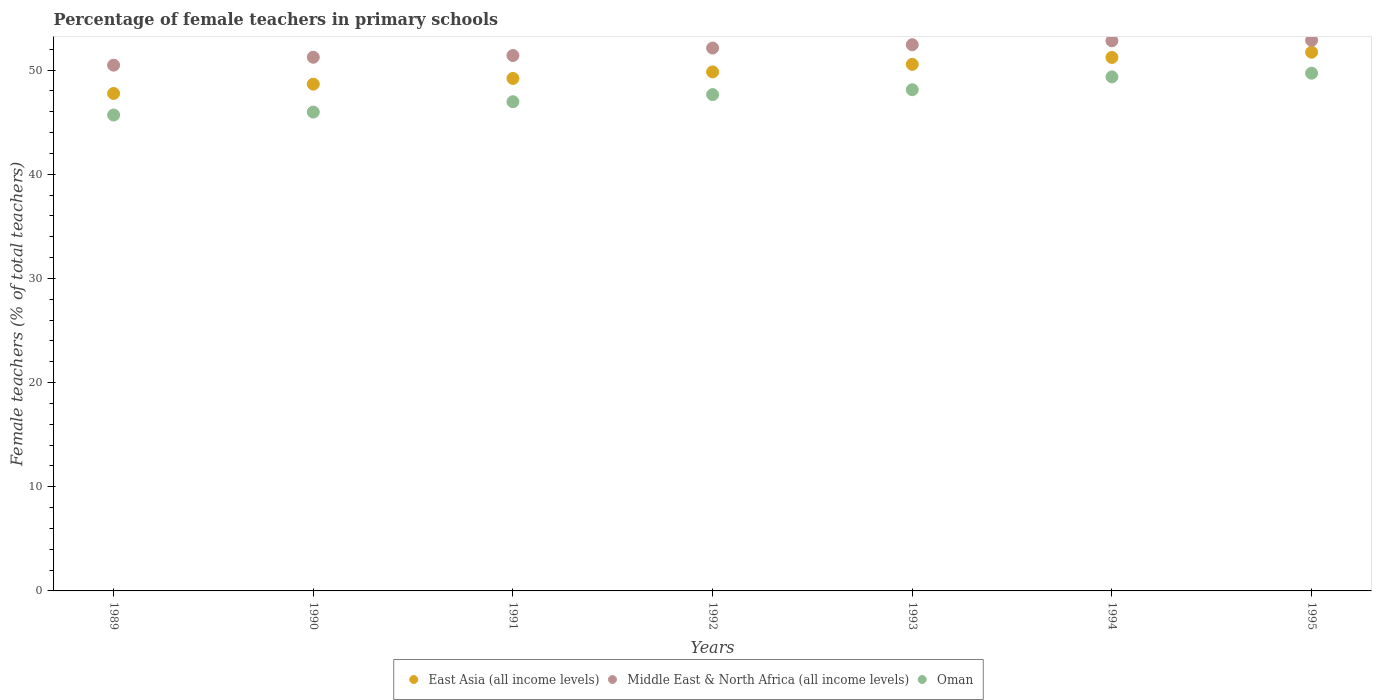Is the number of dotlines equal to the number of legend labels?
Provide a succinct answer. Yes. What is the percentage of female teachers in East Asia (all income levels) in 1993?
Keep it short and to the point. 50.56. Across all years, what is the maximum percentage of female teachers in East Asia (all income levels)?
Ensure brevity in your answer.  51.72. Across all years, what is the minimum percentage of female teachers in Middle East & North Africa (all income levels)?
Ensure brevity in your answer.  50.48. What is the total percentage of female teachers in East Asia (all income levels) in the graph?
Provide a short and direct response. 348.96. What is the difference between the percentage of female teachers in Oman in 1993 and that in 1994?
Your answer should be very brief. -1.23. What is the difference between the percentage of female teachers in Middle East & North Africa (all income levels) in 1989 and the percentage of female teachers in East Asia (all income levels) in 1995?
Ensure brevity in your answer.  -1.24. What is the average percentage of female teachers in East Asia (all income levels) per year?
Make the answer very short. 49.85. In the year 1989, what is the difference between the percentage of female teachers in Oman and percentage of female teachers in Middle East & North Africa (all income levels)?
Provide a succinct answer. -4.79. In how many years, is the percentage of female teachers in Oman greater than 10 %?
Ensure brevity in your answer.  7. What is the ratio of the percentage of female teachers in East Asia (all income levels) in 1990 to that in 1991?
Your response must be concise. 0.99. Is the difference between the percentage of female teachers in Oman in 1989 and 1992 greater than the difference between the percentage of female teachers in Middle East & North Africa (all income levels) in 1989 and 1992?
Your answer should be very brief. No. What is the difference between the highest and the second highest percentage of female teachers in Middle East & North Africa (all income levels)?
Your answer should be very brief. 0.05. What is the difference between the highest and the lowest percentage of female teachers in Oman?
Offer a very short reply. 4.02. In how many years, is the percentage of female teachers in Oman greater than the average percentage of female teachers in Oman taken over all years?
Your answer should be very brief. 4. Is the sum of the percentage of female teachers in Oman in 1991 and 1995 greater than the maximum percentage of female teachers in East Asia (all income levels) across all years?
Offer a terse response. Yes. Does the percentage of female teachers in Oman monotonically increase over the years?
Make the answer very short. Yes. Is the percentage of female teachers in East Asia (all income levels) strictly less than the percentage of female teachers in Middle East & North Africa (all income levels) over the years?
Your answer should be compact. Yes. How many dotlines are there?
Your answer should be compact. 3. How many years are there in the graph?
Your answer should be compact. 7. What is the difference between two consecutive major ticks on the Y-axis?
Keep it short and to the point. 10. Does the graph contain any zero values?
Offer a very short reply. No. What is the title of the graph?
Your answer should be very brief. Percentage of female teachers in primary schools. What is the label or title of the X-axis?
Your response must be concise. Years. What is the label or title of the Y-axis?
Your response must be concise. Female teachers (% of total teachers). What is the Female teachers (% of total teachers) in East Asia (all income levels) in 1989?
Offer a terse response. 47.76. What is the Female teachers (% of total teachers) of Middle East & North Africa (all income levels) in 1989?
Give a very brief answer. 50.48. What is the Female teachers (% of total teachers) of Oman in 1989?
Provide a succinct answer. 45.69. What is the Female teachers (% of total teachers) of East Asia (all income levels) in 1990?
Your answer should be compact. 48.66. What is the Female teachers (% of total teachers) in Middle East & North Africa (all income levels) in 1990?
Offer a terse response. 51.24. What is the Female teachers (% of total teachers) in Oman in 1990?
Your answer should be very brief. 45.98. What is the Female teachers (% of total teachers) in East Asia (all income levels) in 1991?
Make the answer very short. 49.21. What is the Female teachers (% of total teachers) of Middle East & North Africa (all income levels) in 1991?
Keep it short and to the point. 51.41. What is the Female teachers (% of total teachers) in Oman in 1991?
Give a very brief answer. 46.97. What is the Female teachers (% of total teachers) in East Asia (all income levels) in 1992?
Provide a succinct answer. 49.83. What is the Female teachers (% of total teachers) of Middle East & North Africa (all income levels) in 1992?
Provide a short and direct response. 52.12. What is the Female teachers (% of total teachers) in Oman in 1992?
Offer a very short reply. 47.65. What is the Female teachers (% of total teachers) of East Asia (all income levels) in 1993?
Keep it short and to the point. 50.56. What is the Female teachers (% of total teachers) in Middle East & North Africa (all income levels) in 1993?
Give a very brief answer. 52.44. What is the Female teachers (% of total teachers) of Oman in 1993?
Keep it short and to the point. 48.12. What is the Female teachers (% of total teachers) in East Asia (all income levels) in 1994?
Keep it short and to the point. 51.22. What is the Female teachers (% of total teachers) in Middle East & North Africa (all income levels) in 1994?
Offer a very short reply. 52.82. What is the Female teachers (% of total teachers) of Oman in 1994?
Ensure brevity in your answer.  49.35. What is the Female teachers (% of total teachers) in East Asia (all income levels) in 1995?
Give a very brief answer. 51.72. What is the Female teachers (% of total teachers) of Middle East & North Africa (all income levels) in 1995?
Offer a very short reply. 52.87. What is the Female teachers (% of total teachers) of Oman in 1995?
Your response must be concise. 49.71. Across all years, what is the maximum Female teachers (% of total teachers) of East Asia (all income levels)?
Your answer should be very brief. 51.72. Across all years, what is the maximum Female teachers (% of total teachers) of Middle East & North Africa (all income levels)?
Ensure brevity in your answer.  52.87. Across all years, what is the maximum Female teachers (% of total teachers) in Oman?
Your response must be concise. 49.71. Across all years, what is the minimum Female teachers (% of total teachers) of East Asia (all income levels)?
Keep it short and to the point. 47.76. Across all years, what is the minimum Female teachers (% of total teachers) in Middle East & North Africa (all income levels)?
Offer a very short reply. 50.48. Across all years, what is the minimum Female teachers (% of total teachers) in Oman?
Your answer should be compact. 45.69. What is the total Female teachers (% of total teachers) in East Asia (all income levels) in the graph?
Ensure brevity in your answer.  348.96. What is the total Female teachers (% of total teachers) of Middle East & North Africa (all income levels) in the graph?
Your answer should be compact. 363.38. What is the total Female teachers (% of total teachers) in Oman in the graph?
Your response must be concise. 333.47. What is the difference between the Female teachers (% of total teachers) of East Asia (all income levels) in 1989 and that in 1990?
Your response must be concise. -0.9. What is the difference between the Female teachers (% of total teachers) in Middle East & North Africa (all income levels) in 1989 and that in 1990?
Your response must be concise. -0.76. What is the difference between the Female teachers (% of total teachers) in Oman in 1989 and that in 1990?
Give a very brief answer. -0.29. What is the difference between the Female teachers (% of total teachers) of East Asia (all income levels) in 1989 and that in 1991?
Your response must be concise. -1.44. What is the difference between the Female teachers (% of total teachers) in Middle East & North Africa (all income levels) in 1989 and that in 1991?
Your answer should be compact. -0.92. What is the difference between the Female teachers (% of total teachers) in Oman in 1989 and that in 1991?
Give a very brief answer. -1.28. What is the difference between the Female teachers (% of total teachers) in East Asia (all income levels) in 1989 and that in 1992?
Your answer should be very brief. -2.07. What is the difference between the Female teachers (% of total teachers) in Middle East & North Africa (all income levels) in 1989 and that in 1992?
Provide a short and direct response. -1.64. What is the difference between the Female teachers (% of total teachers) in Oman in 1989 and that in 1992?
Give a very brief answer. -1.96. What is the difference between the Female teachers (% of total teachers) of East Asia (all income levels) in 1989 and that in 1993?
Offer a terse response. -2.8. What is the difference between the Female teachers (% of total teachers) of Middle East & North Africa (all income levels) in 1989 and that in 1993?
Give a very brief answer. -1.96. What is the difference between the Female teachers (% of total teachers) in Oman in 1989 and that in 1993?
Offer a terse response. -2.43. What is the difference between the Female teachers (% of total teachers) in East Asia (all income levels) in 1989 and that in 1994?
Your response must be concise. -3.46. What is the difference between the Female teachers (% of total teachers) of Middle East & North Africa (all income levels) in 1989 and that in 1994?
Keep it short and to the point. -2.34. What is the difference between the Female teachers (% of total teachers) in Oman in 1989 and that in 1994?
Keep it short and to the point. -3.66. What is the difference between the Female teachers (% of total teachers) of East Asia (all income levels) in 1989 and that in 1995?
Offer a very short reply. -3.96. What is the difference between the Female teachers (% of total teachers) in Middle East & North Africa (all income levels) in 1989 and that in 1995?
Offer a terse response. -2.39. What is the difference between the Female teachers (% of total teachers) of Oman in 1989 and that in 1995?
Offer a terse response. -4.02. What is the difference between the Female teachers (% of total teachers) of East Asia (all income levels) in 1990 and that in 1991?
Your answer should be very brief. -0.55. What is the difference between the Female teachers (% of total teachers) in Middle East & North Africa (all income levels) in 1990 and that in 1991?
Make the answer very short. -0.16. What is the difference between the Female teachers (% of total teachers) of Oman in 1990 and that in 1991?
Offer a very short reply. -0.99. What is the difference between the Female teachers (% of total teachers) in East Asia (all income levels) in 1990 and that in 1992?
Ensure brevity in your answer.  -1.17. What is the difference between the Female teachers (% of total teachers) in Middle East & North Africa (all income levels) in 1990 and that in 1992?
Your response must be concise. -0.88. What is the difference between the Female teachers (% of total teachers) in Oman in 1990 and that in 1992?
Give a very brief answer. -1.68. What is the difference between the Female teachers (% of total teachers) in East Asia (all income levels) in 1990 and that in 1993?
Provide a short and direct response. -1.9. What is the difference between the Female teachers (% of total teachers) of Middle East & North Africa (all income levels) in 1990 and that in 1993?
Your answer should be compact. -1.2. What is the difference between the Female teachers (% of total teachers) of Oman in 1990 and that in 1993?
Provide a short and direct response. -2.15. What is the difference between the Female teachers (% of total teachers) in East Asia (all income levels) in 1990 and that in 1994?
Your answer should be very brief. -2.56. What is the difference between the Female teachers (% of total teachers) in Middle East & North Africa (all income levels) in 1990 and that in 1994?
Keep it short and to the point. -1.58. What is the difference between the Female teachers (% of total teachers) in Oman in 1990 and that in 1994?
Make the answer very short. -3.38. What is the difference between the Female teachers (% of total teachers) in East Asia (all income levels) in 1990 and that in 1995?
Make the answer very short. -3.07. What is the difference between the Female teachers (% of total teachers) in Middle East & North Africa (all income levels) in 1990 and that in 1995?
Offer a very short reply. -1.63. What is the difference between the Female teachers (% of total teachers) of Oman in 1990 and that in 1995?
Make the answer very short. -3.73. What is the difference between the Female teachers (% of total teachers) of East Asia (all income levels) in 1991 and that in 1992?
Make the answer very short. -0.63. What is the difference between the Female teachers (% of total teachers) of Middle East & North Africa (all income levels) in 1991 and that in 1992?
Ensure brevity in your answer.  -0.72. What is the difference between the Female teachers (% of total teachers) of Oman in 1991 and that in 1992?
Your response must be concise. -0.68. What is the difference between the Female teachers (% of total teachers) in East Asia (all income levels) in 1991 and that in 1993?
Give a very brief answer. -1.35. What is the difference between the Female teachers (% of total teachers) of Middle East & North Africa (all income levels) in 1991 and that in 1993?
Offer a terse response. -1.04. What is the difference between the Female teachers (% of total teachers) of Oman in 1991 and that in 1993?
Offer a very short reply. -1.15. What is the difference between the Female teachers (% of total teachers) in East Asia (all income levels) in 1991 and that in 1994?
Your answer should be compact. -2.02. What is the difference between the Female teachers (% of total teachers) in Middle East & North Africa (all income levels) in 1991 and that in 1994?
Your answer should be compact. -1.41. What is the difference between the Female teachers (% of total teachers) in Oman in 1991 and that in 1994?
Provide a short and direct response. -2.39. What is the difference between the Female teachers (% of total teachers) of East Asia (all income levels) in 1991 and that in 1995?
Give a very brief answer. -2.52. What is the difference between the Female teachers (% of total teachers) of Middle East & North Africa (all income levels) in 1991 and that in 1995?
Offer a terse response. -1.46. What is the difference between the Female teachers (% of total teachers) in Oman in 1991 and that in 1995?
Offer a terse response. -2.74. What is the difference between the Female teachers (% of total teachers) in East Asia (all income levels) in 1992 and that in 1993?
Keep it short and to the point. -0.73. What is the difference between the Female teachers (% of total teachers) of Middle East & North Africa (all income levels) in 1992 and that in 1993?
Make the answer very short. -0.32. What is the difference between the Female teachers (% of total teachers) of Oman in 1992 and that in 1993?
Offer a very short reply. -0.47. What is the difference between the Female teachers (% of total teachers) in East Asia (all income levels) in 1992 and that in 1994?
Your answer should be compact. -1.39. What is the difference between the Female teachers (% of total teachers) in Middle East & North Africa (all income levels) in 1992 and that in 1994?
Provide a short and direct response. -0.69. What is the difference between the Female teachers (% of total teachers) in Oman in 1992 and that in 1994?
Provide a succinct answer. -1.7. What is the difference between the Female teachers (% of total teachers) of East Asia (all income levels) in 1992 and that in 1995?
Offer a terse response. -1.89. What is the difference between the Female teachers (% of total teachers) of Middle East & North Africa (all income levels) in 1992 and that in 1995?
Ensure brevity in your answer.  -0.74. What is the difference between the Female teachers (% of total teachers) in Oman in 1992 and that in 1995?
Keep it short and to the point. -2.05. What is the difference between the Female teachers (% of total teachers) in East Asia (all income levels) in 1993 and that in 1994?
Keep it short and to the point. -0.66. What is the difference between the Female teachers (% of total teachers) in Middle East & North Africa (all income levels) in 1993 and that in 1994?
Ensure brevity in your answer.  -0.37. What is the difference between the Female teachers (% of total teachers) in Oman in 1993 and that in 1994?
Make the answer very short. -1.23. What is the difference between the Female teachers (% of total teachers) of East Asia (all income levels) in 1993 and that in 1995?
Your answer should be compact. -1.16. What is the difference between the Female teachers (% of total teachers) in Middle East & North Africa (all income levels) in 1993 and that in 1995?
Make the answer very short. -0.42. What is the difference between the Female teachers (% of total teachers) in Oman in 1993 and that in 1995?
Your answer should be very brief. -1.58. What is the difference between the Female teachers (% of total teachers) in East Asia (all income levels) in 1994 and that in 1995?
Your answer should be very brief. -0.5. What is the difference between the Female teachers (% of total teachers) of Oman in 1994 and that in 1995?
Offer a terse response. -0.35. What is the difference between the Female teachers (% of total teachers) of East Asia (all income levels) in 1989 and the Female teachers (% of total teachers) of Middle East & North Africa (all income levels) in 1990?
Your answer should be compact. -3.48. What is the difference between the Female teachers (% of total teachers) in East Asia (all income levels) in 1989 and the Female teachers (% of total teachers) in Oman in 1990?
Your answer should be compact. 1.79. What is the difference between the Female teachers (% of total teachers) in Middle East & North Africa (all income levels) in 1989 and the Female teachers (% of total teachers) in Oman in 1990?
Give a very brief answer. 4.5. What is the difference between the Female teachers (% of total teachers) in East Asia (all income levels) in 1989 and the Female teachers (% of total teachers) in Middle East & North Africa (all income levels) in 1991?
Make the answer very short. -3.64. What is the difference between the Female teachers (% of total teachers) in East Asia (all income levels) in 1989 and the Female teachers (% of total teachers) in Oman in 1991?
Provide a succinct answer. 0.79. What is the difference between the Female teachers (% of total teachers) of Middle East & North Africa (all income levels) in 1989 and the Female teachers (% of total teachers) of Oman in 1991?
Offer a very short reply. 3.51. What is the difference between the Female teachers (% of total teachers) in East Asia (all income levels) in 1989 and the Female teachers (% of total teachers) in Middle East & North Africa (all income levels) in 1992?
Your response must be concise. -4.36. What is the difference between the Female teachers (% of total teachers) of East Asia (all income levels) in 1989 and the Female teachers (% of total teachers) of Oman in 1992?
Provide a succinct answer. 0.11. What is the difference between the Female teachers (% of total teachers) of Middle East & North Africa (all income levels) in 1989 and the Female teachers (% of total teachers) of Oman in 1992?
Provide a succinct answer. 2.83. What is the difference between the Female teachers (% of total teachers) in East Asia (all income levels) in 1989 and the Female teachers (% of total teachers) in Middle East & North Africa (all income levels) in 1993?
Your response must be concise. -4.68. What is the difference between the Female teachers (% of total teachers) of East Asia (all income levels) in 1989 and the Female teachers (% of total teachers) of Oman in 1993?
Your response must be concise. -0.36. What is the difference between the Female teachers (% of total teachers) in Middle East & North Africa (all income levels) in 1989 and the Female teachers (% of total teachers) in Oman in 1993?
Provide a short and direct response. 2.36. What is the difference between the Female teachers (% of total teachers) in East Asia (all income levels) in 1989 and the Female teachers (% of total teachers) in Middle East & North Africa (all income levels) in 1994?
Ensure brevity in your answer.  -5.05. What is the difference between the Female teachers (% of total teachers) of East Asia (all income levels) in 1989 and the Female teachers (% of total teachers) of Oman in 1994?
Provide a short and direct response. -1.59. What is the difference between the Female teachers (% of total teachers) of Middle East & North Africa (all income levels) in 1989 and the Female teachers (% of total teachers) of Oman in 1994?
Give a very brief answer. 1.13. What is the difference between the Female teachers (% of total teachers) of East Asia (all income levels) in 1989 and the Female teachers (% of total teachers) of Middle East & North Africa (all income levels) in 1995?
Offer a terse response. -5.1. What is the difference between the Female teachers (% of total teachers) of East Asia (all income levels) in 1989 and the Female teachers (% of total teachers) of Oman in 1995?
Your answer should be very brief. -1.94. What is the difference between the Female teachers (% of total teachers) in Middle East & North Africa (all income levels) in 1989 and the Female teachers (% of total teachers) in Oman in 1995?
Provide a succinct answer. 0.77. What is the difference between the Female teachers (% of total teachers) of East Asia (all income levels) in 1990 and the Female teachers (% of total teachers) of Middle East & North Africa (all income levels) in 1991?
Your response must be concise. -2.75. What is the difference between the Female teachers (% of total teachers) in East Asia (all income levels) in 1990 and the Female teachers (% of total teachers) in Oman in 1991?
Provide a short and direct response. 1.69. What is the difference between the Female teachers (% of total teachers) of Middle East & North Africa (all income levels) in 1990 and the Female teachers (% of total teachers) of Oman in 1991?
Your answer should be compact. 4.27. What is the difference between the Female teachers (% of total teachers) of East Asia (all income levels) in 1990 and the Female teachers (% of total teachers) of Middle East & North Africa (all income levels) in 1992?
Offer a very short reply. -3.47. What is the difference between the Female teachers (% of total teachers) in Middle East & North Africa (all income levels) in 1990 and the Female teachers (% of total teachers) in Oman in 1992?
Provide a short and direct response. 3.59. What is the difference between the Female teachers (% of total teachers) of East Asia (all income levels) in 1990 and the Female teachers (% of total teachers) of Middle East & North Africa (all income levels) in 1993?
Ensure brevity in your answer.  -3.79. What is the difference between the Female teachers (% of total teachers) of East Asia (all income levels) in 1990 and the Female teachers (% of total teachers) of Oman in 1993?
Provide a succinct answer. 0.54. What is the difference between the Female teachers (% of total teachers) of Middle East & North Africa (all income levels) in 1990 and the Female teachers (% of total teachers) of Oman in 1993?
Give a very brief answer. 3.12. What is the difference between the Female teachers (% of total teachers) of East Asia (all income levels) in 1990 and the Female teachers (% of total teachers) of Middle East & North Africa (all income levels) in 1994?
Make the answer very short. -4.16. What is the difference between the Female teachers (% of total teachers) in East Asia (all income levels) in 1990 and the Female teachers (% of total teachers) in Oman in 1994?
Your answer should be compact. -0.7. What is the difference between the Female teachers (% of total teachers) of Middle East & North Africa (all income levels) in 1990 and the Female teachers (% of total teachers) of Oman in 1994?
Offer a terse response. 1.89. What is the difference between the Female teachers (% of total teachers) in East Asia (all income levels) in 1990 and the Female teachers (% of total teachers) in Middle East & North Africa (all income levels) in 1995?
Provide a succinct answer. -4.21. What is the difference between the Female teachers (% of total teachers) of East Asia (all income levels) in 1990 and the Female teachers (% of total teachers) of Oman in 1995?
Offer a terse response. -1.05. What is the difference between the Female teachers (% of total teachers) of Middle East & North Africa (all income levels) in 1990 and the Female teachers (% of total teachers) of Oman in 1995?
Your answer should be very brief. 1.53. What is the difference between the Female teachers (% of total teachers) of East Asia (all income levels) in 1991 and the Female teachers (% of total teachers) of Middle East & North Africa (all income levels) in 1992?
Ensure brevity in your answer.  -2.92. What is the difference between the Female teachers (% of total teachers) of East Asia (all income levels) in 1991 and the Female teachers (% of total teachers) of Oman in 1992?
Provide a succinct answer. 1.55. What is the difference between the Female teachers (% of total teachers) in Middle East & North Africa (all income levels) in 1991 and the Female teachers (% of total teachers) in Oman in 1992?
Provide a succinct answer. 3.75. What is the difference between the Female teachers (% of total teachers) in East Asia (all income levels) in 1991 and the Female teachers (% of total teachers) in Middle East & North Africa (all income levels) in 1993?
Offer a terse response. -3.24. What is the difference between the Female teachers (% of total teachers) of East Asia (all income levels) in 1991 and the Female teachers (% of total teachers) of Oman in 1993?
Offer a very short reply. 1.08. What is the difference between the Female teachers (% of total teachers) in Middle East & North Africa (all income levels) in 1991 and the Female teachers (% of total teachers) in Oman in 1993?
Your response must be concise. 3.28. What is the difference between the Female teachers (% of total teachers) of East Asia (all income levels) in 1991 and the Female teachers (% of total teachers) of Middle East & North Africa (all income levels) in 1994?
Make the answer very short. -3.61. What is the difference between the Female teachers (% of total teachers) in East Asia (all income levels) in 1991 and the Female teachers (% of total teachers) in Oman in 1994?
Provide a short and direct response. -0.15. What is the difference between the Female teachers (% of total teachers) in Middle East & North Africa (all income levels) in 1991 and the Female teachers (% of total teachers) in Oman in 1994?
Ensure brevity in your answer.  2.05. What is the difference between the Female teachers (% of total teachers) in East Asia (all income levels) in 1991 and the Female teachers (% of total teachers) in Middle East & North Africa (all income levels) in 1995?
Keep it short and to the point. -3.66. What is the difference between the Female teachers (% of total teachers) of East Asia (all income levels) in 1991 and the Female teachers (% of total teachers) of Oman in 1995?
Your answer should be very brief. -0.5. What is the difference between the Female teachers (% of total teachers) of Middle East & North Africa (all income levels) in 1991 and the Female teachers (% of total teachers) of Oman in 1995?
Offer a very short reply. 1.7. What is the difference between the Female teachers (% of total teachers) in East Asia (all income levels) in 1992 and the Female teachers (% of total teachers) in Middle East & North Africa (all income levels) in 1993?
Offer a very short reply. -2.61. What is the difference between the Female teachers (% of total teachers) of East Asia (all income levels) in 1992 and the Female teachers (% of total teachers) of Oman in 1993?
Offer a terse response. 1.71. What is the difference between the Female teachers (% of total teachers) of Middle East & North Africa (all income levels) in 1992 and the Female teachers (% of total teachers) of Oman in 1993?
Give a very brief answer. 4. What is the difference between the Female teachers (% of total teachers) in East Asia (all income levels) in 1992 and the Female teachers (% of total teachers) in Middle East & North Africa (all income levels) in 1994?
Offer a terse response. -2.98. What is the difference between the Female teachers (% of total teachers) in East Asia (all income levels) in 1992 and the Female teachers (% of total teachers) in Oman in 1994?
Give a very brief answer. 0.48. What is the difference between the Female teachers (% of total teachers) of Middle East & North Africa (all income levels) in 1992 and the Female teachers (% of total teachers) of Oman in 1994?
Provide a succinct answer. 2.77. What is the difference between the Female teachers (% of total teachers) in East Asia (all income levels) in 1992 and the Female teachers (% of total teachers) in Middle East & North Africa (all income levels) in 1995?
Offer a very short reply. -3.03. What is the difference between the Female teachers (% of total teachers) of East Asia (all income levels) in 1992 and the Female teachers (% of total teachers) of Oman in 1995?
Make the answer very short. 0.12. What is the difference between the Female teachers (% of total teachers) of Middle East & North Africa (all income levels) in 1992 and the Female teachers (% of total teachers) of Oman in 1995?
Provide a succinct answer. 2.42. What is the difference between the Female teachers (% of total teachers) of East Asia (all income levels) in 1993 and the Female teachers (% of total teachers) of Middle East & North Africa (all income levels) in 1994?
Provide a short and direct response. -2.26. What is the difference between the Female teachers (% of total teachers) of East Asia (all income levels) in 1993 and the Female teachers (% of total teachers) of Oman in 1994?
Make the answer very short. 1.2. What is the difference between the Female teachers (% of total teachers) in Middle East & North Africa (all income levels) in 1993 and the Female teachers (% of total teachers) in Oman in 1994?
Give a very brief answer. 3.09. What is the difference between the Female teachers (% of total teachers) in East Asia (all income levels) in 1993 and the Female teachers (% of total teachers) in Middle East & North Africa (all income levels) in 1995?
Give a very brief answer. -2.31. What is the difference between the Female teachers (% of total teachers) of East Asia (all income levels) in 1993 and the Female teachers (% of total teachers) of Oman in 1995?
Your answer should be very brief. 0.85. What is the difference between the Female teachers (% of total teachers) of Middle East & North Africa (all income levels) in 1993 and the Female teachers (% of total teachers) of Oman in 1995?
Your response must be concise. 2.74. What is the difference between the Female teachers (% of total teachers) of East Asia (all income levels) in 1994 and the Female teachers (% of total teachers) of Middle East & North Africa (all income levels) in 1995?
Keep it short and to the point. -1.64. What is the difference between the Female teachers (% of total teachers) of East Asia (all income levels) in 1994 and the Female teachers (% of total teachers) of Oman in 1995?
Offer a terse response. 1.51. What is the difference between the Female teachers (% of total teachers) of Middle East & North Africa (all income levels) in 1994 and the Female teachers (% of total teachers) of Oman in 1995?
Offer a terse response. 3.11. What is the average Female teachers (% of total teachers) in East Asia (all income levels) per year?
Keep it short and to the point. 49.85. What is the average Female teachers (% of total teachers) in Middle East & North Africa (all income levels) per year?
Provide a short and direct response. 51.91. What is the average Female teachers (% of total teachers) in Oman per year?
Give a very brief answer. 47.64. In the year 1989, what is the difference between the Female teachers (% of total teachers) in East Asia (all income levels) and Female teachers (% of total teachers) in Middle East & North Africa (all income levels)?
Offer a terse response. -2.72. In the year 1989, what is the difference between the Female teachers (% of total teachers) in East Asia (all income levels) and Female teachers (% of total teachers) in Oman?
Your response must be concise. 2.07. In the year 1989, what is the difference between the Female teachers (% of total teachers) in Middle East & North Africa (all income levels) and Female teachers (% of total teachers) in Oman?
Your answer should be very brief. 4.79. In the year 1990, what is the difference between the Female teachers (% of total teachers) in East Asia (all income levels) and Female teachers (% of total teachers) in Middle East & North Africa (all income levels)?
Your response must be concise. -2.58. In the year 1990, what is the difference between the Female teachers (% of total teachers) in East Asia (all income levels) and Female teachers (% of total teachers) in Oman?
Provide a succinct answer. 2.68. In the year 1990, what is the difference between the Female teachers (% of total teachers) of Middle East & North Africa (all income levels) and Female teachers (% of total teachers) of Oman?
Your answer should be compact. 5.26. In the year 1991, what is the difference between the Female teachers (% of total teachers) in East Asia (all income levels) and Female teachers (% of total teachers) in Middle East & North Africa (all income levels)?
Provide a short and direct response. -2.2. In the year 1991, what is the difference between the Female teachers (% of total teachers) of East Asia (all income levels) and Female teachers (% of total teachers) of Oman?
Give a very brief answer. 2.24. In the year 1991, what is the difference between the Female teachers (% of total teachers) of Middle East & North Africa (all income levels) and Female teachers (% of total teachers) of Oman?
Provide a succinct answer. 4.44. In the year 1992, what is the difference between the Female teachers (% of total teachers) in East Asia (all income levels) and Female teachers (% of total teachers) in Middle East & North Africa (all income levels)?
Your answer should be compact. -2.29. In the year 1992, what is the difference between the Female teachers (% of total teachers) in East Asia (all income levels) and Female teachers (% of total teachers) in Oman?
Provide a short and direct response. 2.18. In the year 1992, what is the difference between the Female teachers (% of total teachers) of Middle East & North Africa (all income levels) and Female teachers (% of total teachers) of Oman?
Your answer should be very brief. 4.47. In the year 1993, what is the difference between the Female teachers (% of total teachers) in East Asia (all income levels) and Female teachers (% of total teachers) in Middle East & North Africa (all income levels)?
Provide a short and direct response. -1.89. In the year 1993, what is the difference between the Female teachers (% of total teachers) in East Asia (all income levels) and Female teachers (% of total teachers) in Oman?
Provide a succinct answer. 2.44. In the year 1993, what is the difference between the Female teachers (% of total teachers) of Middle East & North Africa (all income levels) and Female teachers (% of total teachers) of Oman?
Give a very brief answer. 4.32. In the year 1994, what is the difference between the Female teachers (% of total teachers) in East Asia (all income levels) and Female teachers (% of total teachers) in Middle East & North Africa (all income levels)?
Offer a terse response. -1.59. In the year 1994, what is the difference between the Female teachers (% of total teachers) of East Asia (all income levels) and Female teachers (% of total teachers) of Oman?
Give a very brief answer. 1.87. In the year 1994, what is the difference between the Female teachers (% of total teachers) in Middle East & North Africa (all income levels) and Female teachers (% of total teachers) in Oman?
Make the answer very short. 3.46. In the year 1995, what is the difference between the Female teachers (% of total teachers) of East Asia (all income levels) and Female teachers (% of total teachers) of Middle East & North Africa (all income levels)?
Your answer should be compact. -1.14. In the year 1995, what is the difference between the Female teachers (% of total teachers) of East Asia (all income levels) and Female teachers (% of total teachers) of Oman?
Your answer should be very brief. 2.02. In the year 1995, what is the difference between the Female teachers (% of total teachers) in Middle East & North Africa (all income levels) and Female teachers (% of total teachers) in Oman?
Provide a succinct answer. 3.16. What is the ratio of the Female teachers (% of total teachers) of East Asia (all income levels) in 1989 to that in 1990?
Offer a terse response. 0.98. What is the ratio of the Female teachers (% of total teachers) in Middle East & North Africa (all income levels) in 1989 to that in 1990?
Provide a succinct answer. 0.99. What is the ratio of the Female teachers (% of total teachers) of Oman in 1989 to that in 1990?
Your answer should be compact. 0.99. What is the ratio of the Female teachers (% of total teachers) of East Asia (all income levels) in 1989 to that in 1991?
Your answer should be very brief. 0.97. What is the ratio of the Female teachers (% of total teachers) in Oman in 1989 to that in 1991?
Make the answer very short. 0.97. What is the ratio of the Female teachers (% of total teachers) in East Asia (all income levels) in 1989 to that in 1992?
Make the answer very short. 0.96. What is the ratio of the Female teachers (% of total teachers) in Middle East & North Africa (all income levels) in 1989 to that in 1992?
Your answer should be very brief. 0.97. What is the ratio of the Female teachers (% of total teachers) in Oman in 1989 to that in 1992?
Offer a very short reply. 0.96. What is the ratio of the Female teachers (% of total teachers) in East Asia (all income levels) in 1989 to that in 1993?
Make the answer very short. 0.94. What is the ratio of the Female teachers (% of total teachers) of Middle East & North Africa (all income levels) in 1989 to that in 1993?
Your answer should be compact. 0.96. What is the ratio of the Female teachers (% of total teachers) of Oman in 1989 to that in 1993?
Provide a short and direct response. 0.95. What is the ratio of the Female teachers (% of total teachers) in East Asia (all income levels) in 1989 to that in 1994?
Make the answer very short. 0.93. What is the ratio of the Female teachers (% of total teachers) of Middle East & North Africa (all income levels) in 1989 to that in 1994?
Your answer should be very brief. 0.96. What is the ratio of the Female teachers (% of total teachers) of Oman in 1989 to that in 1994?
Ensure brevity in your answer.  0.93. What is the ratio of the Female teachers (% of total teachers) of East Asia (all income levels) in 1989 to that in 1995?
Ensure brevity in your answer.  0.92. What is the ratio of the Female teachers (% of total teachers) in Middle East & North Africa (all income levels) in 1989 to that in 1995?
Offer a very short reply. 0.95. What is the ratio of the Female teachers (% of total teachers) in Oman in 1989 to that in 1995?
Ensure brevity in your answer.  0.92. What is the ratio of the Female teachers (% of total teachers) of East Asia (all income levels) in 1990 to that in 1991?
Give a very brief answer. 0.99. What is the ratio of the Female teachers (% of total teachers) in Middle East & North Africa (all income levels) in 1990 to that in 1991?
Provide a succinct answer. 1. What is the ratio of the Female teachers (% of total teachers) in Oman in 1990 to that in 1991?
Keep it short and to the point. 0.98. What is the ratio of the Female teachers (% of total teachers) of East Asia (all income levels) in 1990 to that in 1992?
Offer a very short reply. 0.98. What is the ratio of the Female teachers (% of total teachers) of Middle East & North Africa (all income levels) in 1990 to that in 1992?
Provide a succinct answer. 0.98. What is the ratio of the Female teachers (% of total teachers) in Oman in 1990 to that in 1992?
Provide a succinct answer. 0.96. What is the ratio of the Female teachers (% of total teachers) of East Asia (all income levels) in 1990 to that in 1993?
Provide a short and direct response. 0.96. What is the ratio of the Female teachers (% of total teachers) in Middle East & North Africa (all income levels) in 1990 to that in 1993?
Give a very brief answer. 0.98. What is the ratio of the Female teachers (% of total teachers) in Oman in 1990 to that in 1993?
Provide a short and direct response. 0.96. What is the ratio of the Female teachers (% of total teachers) in East Asia (all income levels) in 1990 to that in 1994?
Your answer should be very brief. 0.95. What is the ratio of the Female teachers (% of total teachers) of Middle East & North Africa (all income levels) in 1990 to that in 1994?
Your answer should be compact. 0.97. What is the ratio of the Female teachers (% of total teachers) of Oman in 1990 to that in 1994?
Ensure brevity in your answer.  0.93. What is the ratio of the Female teachers (% of total teachers) in East Asia (all income levels) in 1990 to that in 1995?
Your response must be concise. 0.94. What is the ratio of the Female teachers (% of total teachers) in Middle East & North Africa (all income levels) in 1990 to that in 1995?
Offer a very short reply. 0.97. What is the ratio of the Female teachers (% of total teachers) of Oman in 1990 to that in 1995?
Offer a very short reply. 0.93. What is the ratio of the Female teachers (% of total teachers) of East Asia (all income levels) in 1991 to that in 1992?
Your response must be concise. 0.99. What is the ratio of the Female teachers (% of total teachers) of Middle East & North Africa (all income levels) in 1991 to that in 1992?
Your response must be concise. 0.99. What is the ratio of the Female teachers (% of total teachers) of Oman in 1991 to that in 1992?
Offer a terse response. 0.99. What is the ratio of the Female teachers (% of total teachers) of East Asia (all income levels) in 1991 to that in 1993?
Make the answer very short. 0.97. What is the ratio of the Female teachers (% of total teachers) of Middle East & North Africa (all income levels) in 1991 to that in 1993?
Provide a succinct answer. 0.98. What is the ratio of the Female teachers (% of total teachers) of East Asia (all income levels) in 1991 to that in 1994?
Offer a terse response. 0.96. What is the ratio of the Female teachers (% of total teachers) of Middle East & North Africa (all income levels) in 1991 to that in 1994?
Your answer should be compact. 0.97. What is the ratio of the Female teachers (% of total teachers) of Oman in 1991 to that in 1994?
Keep it short and to the point. 0.95. What is the ratio of the Female teachers (% of total teachers) in East Asia (all income levels) in 1991 to that in 1995?
Give a very brief answer. 0.95. What is the ratio of the Female teachers (% of total teachers) of Middle East & North Africa (all income levels) in 1991 to that in 1995?
Offer a very short reply. 0.97. What is the ratio of the Female teachers (% of total teachers) of Oman in 1991 to that in 1995?
Keep it short and to the point. 0.94. What is the ratio of the Female teachers (% of total teachers) of East Asia (all income levels) in 1992 to that in 1993?
Your answer should be very brief. 0.99. What is the ratio of the Female teachers (% of total teachers) in Middle East & North Africa (all income levels) in 1992 to that in 1993?
Keep it short and to the point. 0.99. What is the ratio of the Female teachers (% of total teachers) in Oman in 1992 to that in 1993?
Ensure brevity in your answer.  0.99. What is the ratio of the Female teachers (% of total teachers) of East Asia (all income levels) in 1992 to that in 1994?
Ensure brevity in your answer.  0.97. What is the ratio of the Female teachers (% of total teachers) of Middle East & North Africa (all income levels) in 1992 to that in 1994?
Offer a very short reply. 0.99. What is the ratio of the Female teachers (% of total teachers) of Oman in 1992 to that in 1994?
Keep it short and to the point. 0.97. What is the ratio of the Female teachers (% of total teachers) in East Asia (all income levels) in 1992 to that in 1995?
Provide a short and direct response. 0.96. What is the ratio of the Female teachers (% of total teachers) of Middle East & North Africa (all income levels) in 1992 to that in 1995?
Your answer should be very brief. 0.99. What is the ratio of the Female teachers (% of total teachers) of Oman in 1992 to that in 1995?
Give a very brief answer. 0.96. What is the ratio of the Female teachers (% of total teachers) in East Asia (all income levels) in 1993 to that in 1994?
Provide a succinct answer. 0.99. What is the ratio of the Female teachers (% of total teachers) of Oman in 1993 to that in 1994?
Offer a terse response. 0.97. What is the ratio of the Female teachers (% of total teachers) in East Asia (all income levels) in 1993 to that in 1995?
Make the answer very short. 0.98. What is the ratio of the Female teachers (% of total teachers) in Middle East & North Africa (all income levels) in 1993 to that in 1995?
Your response must be concise. 0.99. What is the ratio of the Female teachers (% of total teachers) of Oman in 1993 to that in 1995?
Provide a short and direct response. 0.97. What is the ratio of the Female teachers (% of total teachers) of East Asia (all income levels) in 1994 to that in 1995?
Your answer should be very brief. 0.99. What is the ratio of the Female teachers (% of total teachers) in Middle East & North Africa (all income levels) in 1994 to that in 1995?
Your response must be concise. 1. What is the difference between the highest and the second highest Female teachers (% of total teachers) of East Asia (all income levels)?
Offer a very short reply. 0.5. What is the difference between the highest and the second highest Female teachers (% of total teachers) in Oman?
Provide a short and direct response. 0.35. What is the difference between the highest and the lowest Female teachers (% of total teachers) in East Asia (all income levels)?
Keep it short and to the point. 3.96. What is the difference between the highest and the lowest Female teachers (% of total teachers) in Middle East & North Africa (all income levels)?
Ensure brevity in your answer.  2.39. What is the difference between the highest and the lowest Female teachers (% of total teachers) of Oman?
Give a very brief answer. 4.02. 